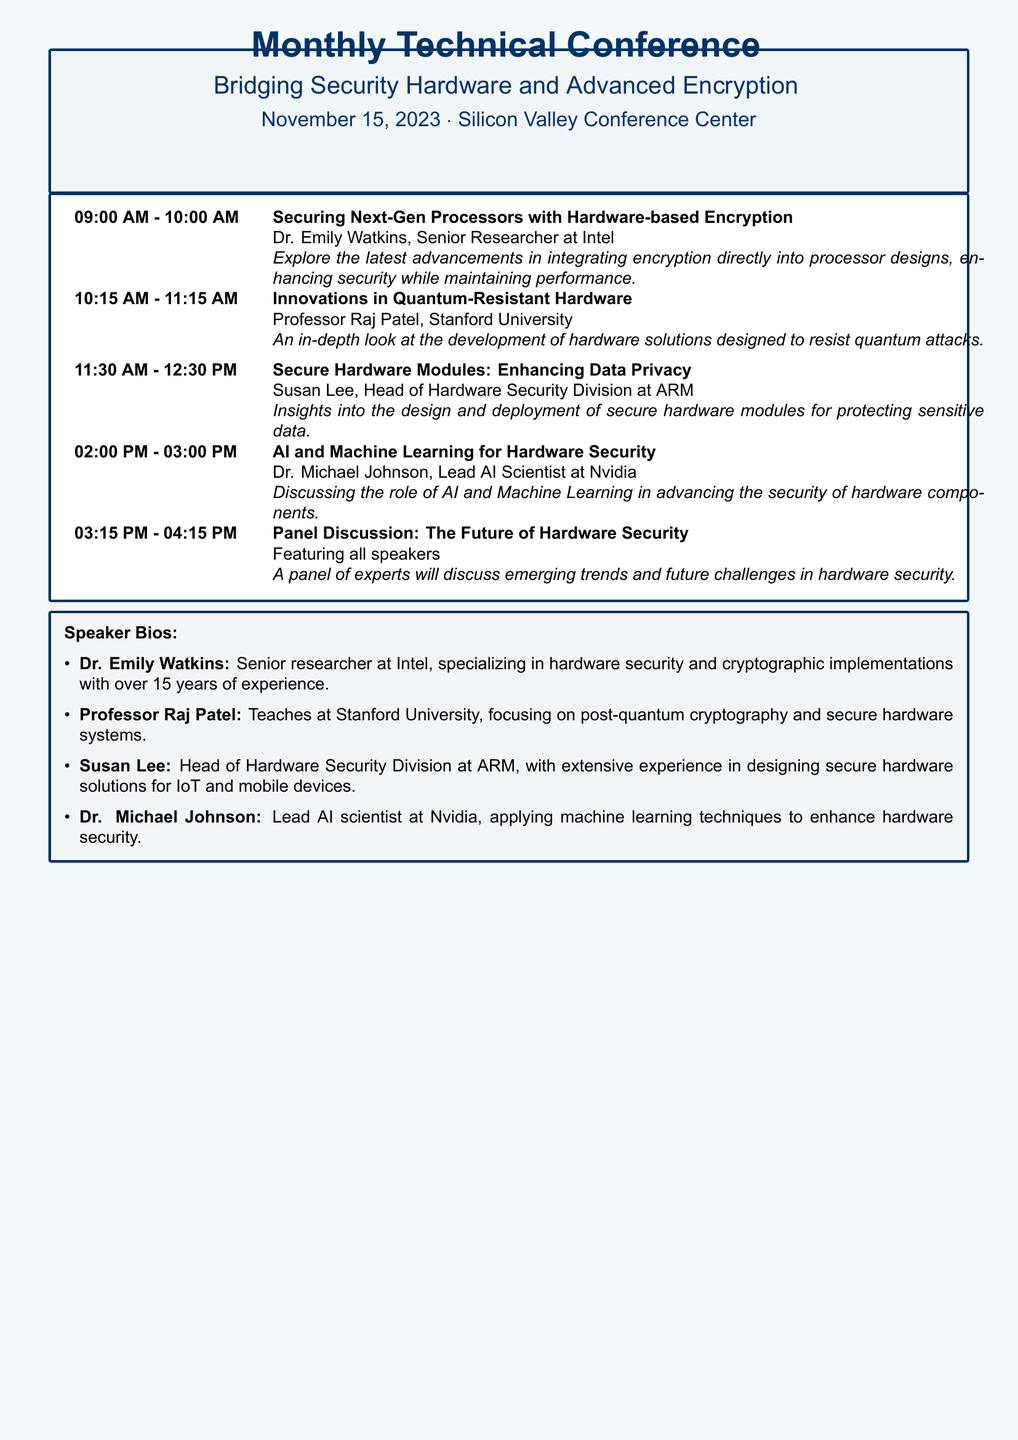What is the date of the conference? The date of the conference is explicitly mentioned in the document.
Answer: November 15, 2023 Who is the speaker for the session on quantum-resistant hardware? The document lists the speaker's name alongside the session title for clarity.
Answer: Professor Raj Patel What time does the panel discussion start? The start time for the panel discussion is shown in the schedule.
Answer: 03:15 PM What is the main focus of Dr. Emily Watkins' session? The abstract of the session provides an overview of the topic being discussed.
Answer: Securing Next-Gen Processors with Hardware-based Encryption How many sessions are there in total? To find the total, one can count the number of sessions listed in the schedule.
Answer: Five What type of bios are included in the document? The document specifies the type of content presented about the speakers.
Answer: Speaker Bios What is the name of the conference center hosting the event? The venue for the conference is mentioned in the heading section of the document.
Answer: Silicon Valley Conference Center Which speaker is associated with AI and machine learning? The speaker’s expertise is detailed in the schedule and bio sections.
Answer: Dr. Michael Johnson What is the title of the last session in the schedule? The document explicitly lists each session title in the agenda.
Answer: Panel Discussion: The Future of Hardware Security 